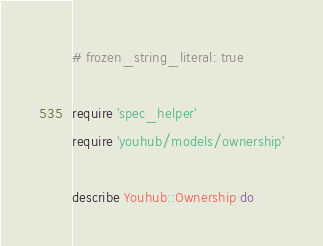Convert code to text. <code><loc_0><loc_0><loc_500><loc_500><_Ruby_># frozen_string_literal: true

require 'spec_helper'
require 'youhub/models/ownership'

describe Youhub::Ownership do</code> 